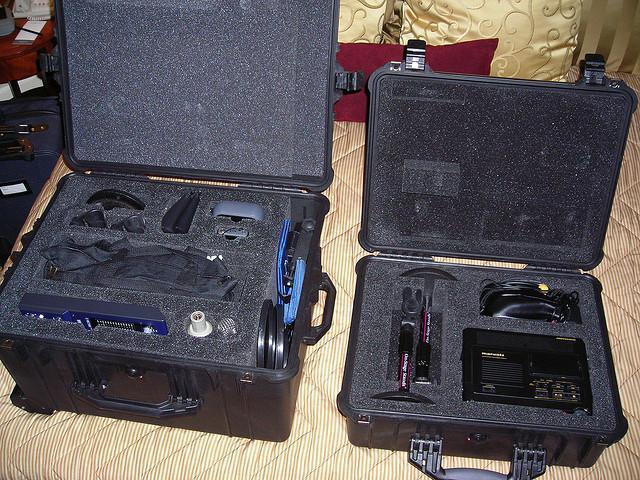How many beds are in the photo?
Give a very brief answer. 1. How many suitcases are there?
Give a very brief answer. 3. 